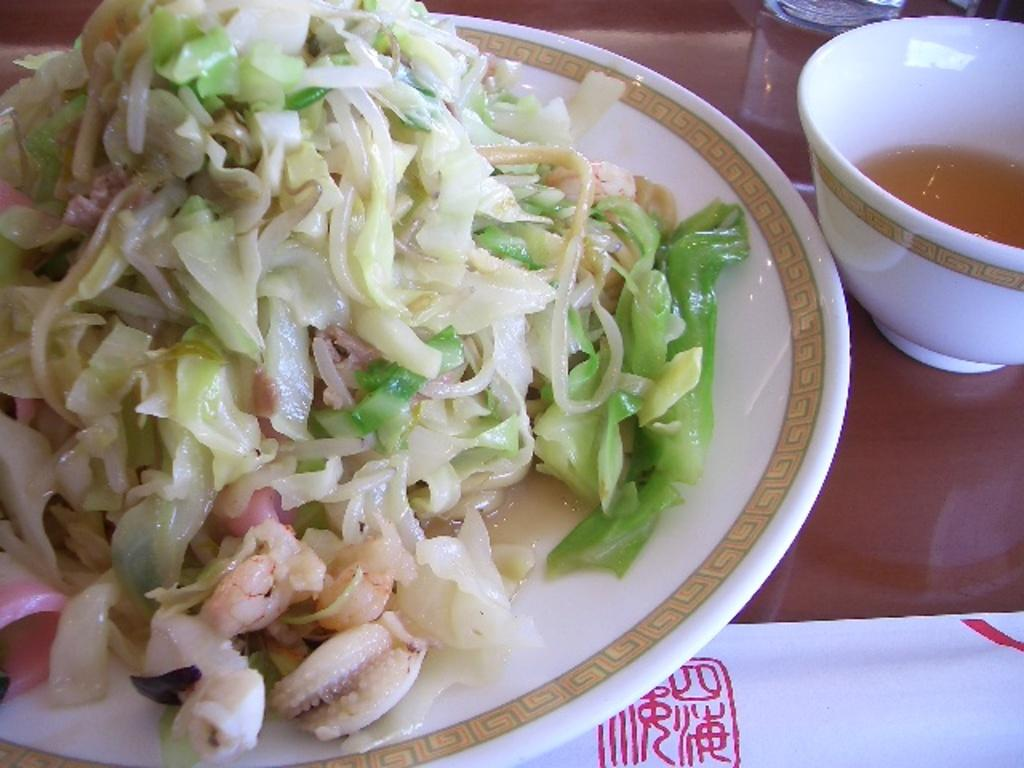What is placed on the plate in the image? There is an edible placed on a plate. What is located beside the plate? There is a bowl of soup beside the plate. What type of jewel is placed on the plate in the image? There is no jewel present on the plate in the image; it contains an edible. What is the purpose of the kettle in the image? There is no kettle present in the image, so it is not possible to determine its purpose. 